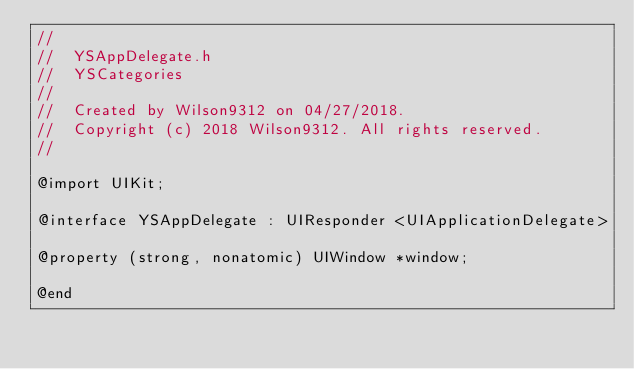<code> <loc_0><loc_0><loc_500><loc_500><_C_>//
//  YSAppDelegate.h
//  YSCategories
//
//  Created by Wilson9312 on 04/27/2018.
//  Copyright (c) 2018 Wilson9312. All rights reserved.
//

@import UIKit;

@interface YSAppDelegate : UIResponder <UIApplicationDelegate>

@property (strong, nonatomic) UIWindow *window;

@end
</code> 